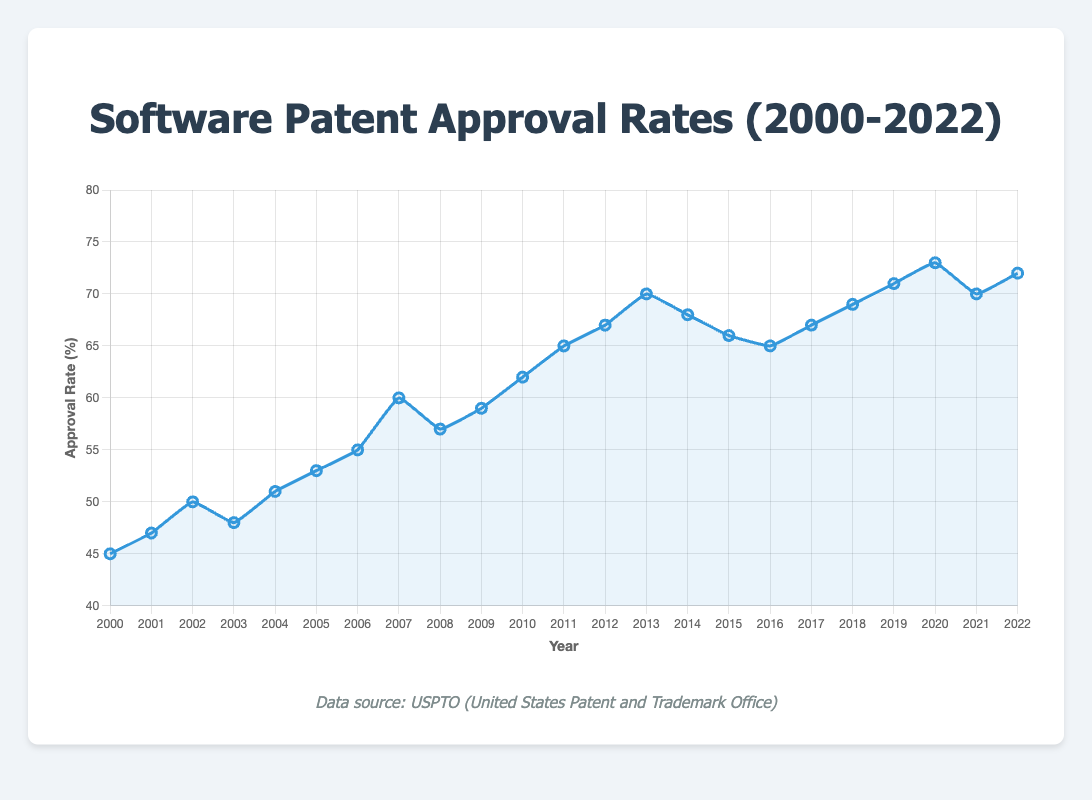What trend do you observe in the approval rates from 2000 to 2022? The approval rates generally increase from 45% in 2000 to a peak of 73% in 2020, with some fluctuations in between, notably a drop around 2014 to 2016. By 2022, it slightly decreased to 72%. This suggests a general upward trend over the years.
Answer: Upward trend In which year did the approval rate peak, and what was the rate? The approval rate peaked in 2020 at 73%. This is identified by observing the highest point on the line plot and noting the corresponding year.
Answer: 2020, 73% During which year/years did the approval rate experience a decline? The line plot shows noticeable declines in approval rate during 2003 (from 50% to 48%), 2008 (from 60% to 57%), and the period from 2014 to 2016 (from 70% to 65%). This involves tracking points where the line decreases between consecutive years.
Answer: 2003, 2008, 2014-2016 How does the approval rate in 2010 compare to that in 2022? In 2010, the approval rate was 62%, whereas in 2022 it was 72%. By comparing these two values, we observe that the rate increased by 10 percentage points.
Answer: The approval rate in 2022 is higher by 10 percentage points What is the average approval rate over the first five years (2000-2004)? The approval rates for the years 2000 to 2004 are 45, 47, 50, 48, and 51. Adding these together gives 241. Dividing by 5 gives the average: 241 / 5 = 48.2%.
Answer: 48.2% Which year witnessed the largest single-year increase in approval rates and what was the percentage increase? From the data, the largest single-year increase occurs between 2006 (55%) and 2007 (60%). The increase is 60% - 55% = 5 percentage points. This is found by checking the differences between consecutive years.
Answer: 2007, 5 percentage points From 2009 to 2012, what is the average yearly increase in approval rate? Approval rates from 2009 to 2012 are 59%, 62%, 65%, and 67%. The year-by-year increases are 62%−59% = 3%, 65%−62% = 3%, and 67%−65% = 2%. Adding these increases gives 3+3+2 = 8%. Dividing by the number of years (3) gives 8 / 3 ≈ 2.67% per year on average.
Answer: 2.67% per year Is there any period of two consecutive years where the approval rate remained the same? Observing the line plot and the data, all years have some change in the approval rate from one year to the next except for 2016 to 2017 where the rate stays at 65%. This is found by checking adjacent values in the dataset.
Answer: No, approval rate changed every year Identify the years when the approval rate was exactly 70%. Checking the line plot, the approval rate reaches exactly 70% in 2013 and 2021. These are the points where the line touches the 70% mark on the y-axis.
Answer: 2013, 2021 